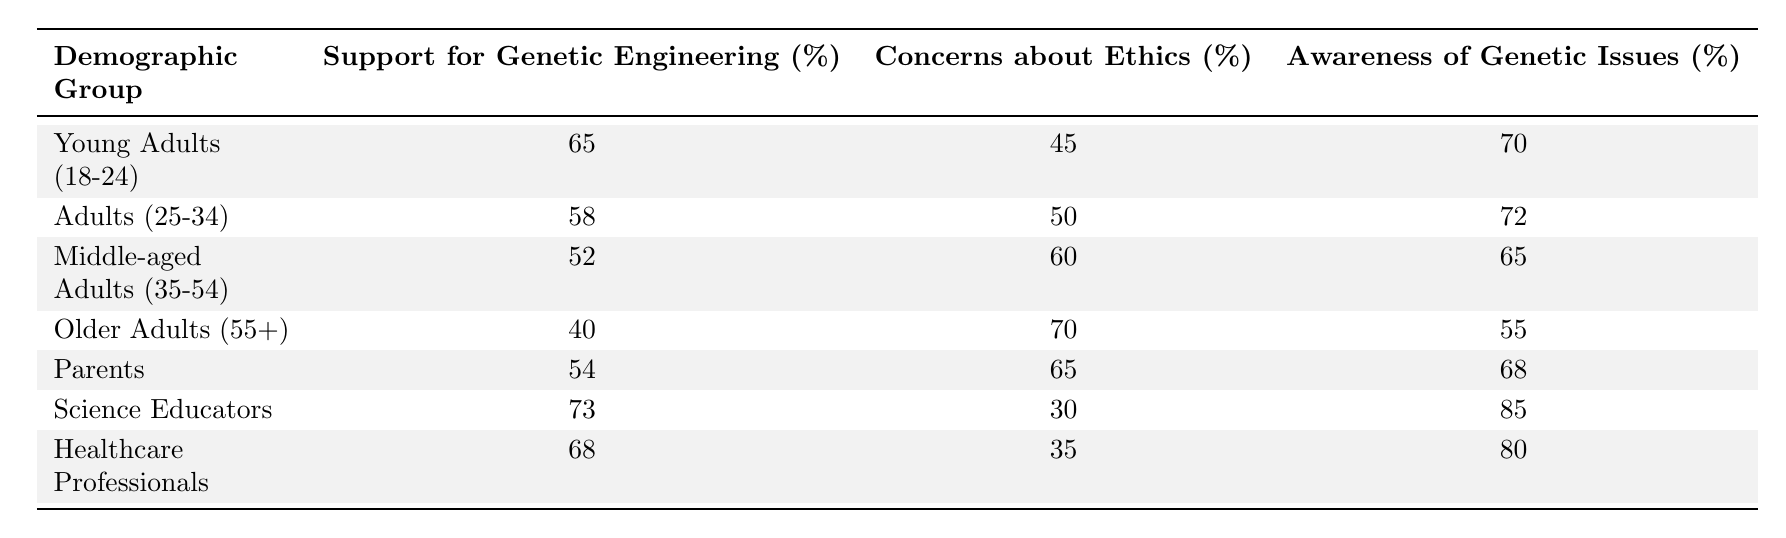What is the support percentage for genetic engineering among Science Educators? The support percentage for Science Educators is found directly in the table, listed under the "Support for Genetic Engineering (%)" column for their demographic group, which is 73%.
Answer: 73% What percentage of Older Adults expressed concerns about ethics? The percentage of concerns about ethics for Older Adults is directly found in the table, listed under the "Concerns about Ethics (%)" column, which is 70%.
Answer: 70% Which demographic group has the highest level of awareness of genetic issues? By comparing the values in the "Awareness of Genetic Issues (%)" column, Science Educators have the highest percentage at 85%.
Answer: Science Educators What is the average support for genetic engineering across all demographic groups? The support percentages are 65, 58, 52, 40, 54, 73, and 68. By summing these values (65 + 58 + 52 + 40 + 54 + 73 + 68 = 410) and dividing by the number of groups (7), we get an average of approximately 58.57.
Answer: Approximately 58.57 Is it true that less than half of Older Adults support genetic engineering? The support percentage for Older Adults is 40%, which is indeed less than half (50%). Therefore, the statement is true.
Answer: True What is the difference in concerns about ethics between Young Adults and Parents? The percentage for Young Adults is 45%, while for Parents it is 65%. The difference is calculated by subtracting Young Adults' percentage from Parents' percentage (65 - 45 = 20).
Answer: 20 Among all demographic groups, which has the lowest awareness of genetic issues? By comparing the values in the "Awareness of Genetic Issues (%)" column, Older Adults show the lowest awareness at 55%.
Answer: Older Adults If we sum all the support percentages for genetic engineering, what do we get? Summing all support percentages (65 + 58 + 52 + 40 + 54 + 73 + 68 = 410) gives us a total of 410%.
Answer: 410% What percentage of Science Educators are concerned about ethics? In the table for Science Educators, the percentage concerned about ethics is found in the "Concerns about Ethics (%)" column, which is 30%.
Answer: 30% 